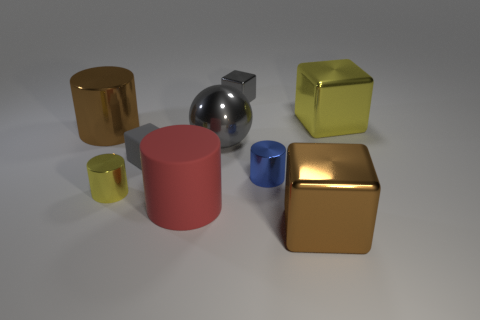What size is the metallic block that is the same color as the ball?
Keep it short and to the point. Small. What number of small yellow cylinders are on the right side of the red rubber cylinder that is to the left of the large metal ball?
Your answer should be very brief. 0. How many other objects are there of the same material as the tiny blue cylinder?
Your answer should be very brief. 6. Is the material of the object on the right side of the brown block the same as the small cylinder on the left side of the big red matte object?
Keep it short and to the point. Yes. Is there anything else that has the same shape as the gray matte object?
Provide a short and direct response. Yes. Are the yellow cylinder and the yellow thing that is right of the big brown block made of the same material?
Your response must be concise. Yes. There is a block that is in front of the large red cylinder that is on the left side of the big block to the left of the large yellow shiny cube; what color is it?
Make the answer very short. Brown. What is the shape of the yellow thing that is the same size as the rubber block?
Your answer should be very brief. Cylinder. Is there anything else that has the same size as the blue metallic thing?
Ensure brevity in your answer.  Yes. There is a yellow metal object that is on the right side of the small gray metal cube; does it have the same size as the cylinder that is behind the small gray matte cube?
Keep it short and to the point. Yes. 